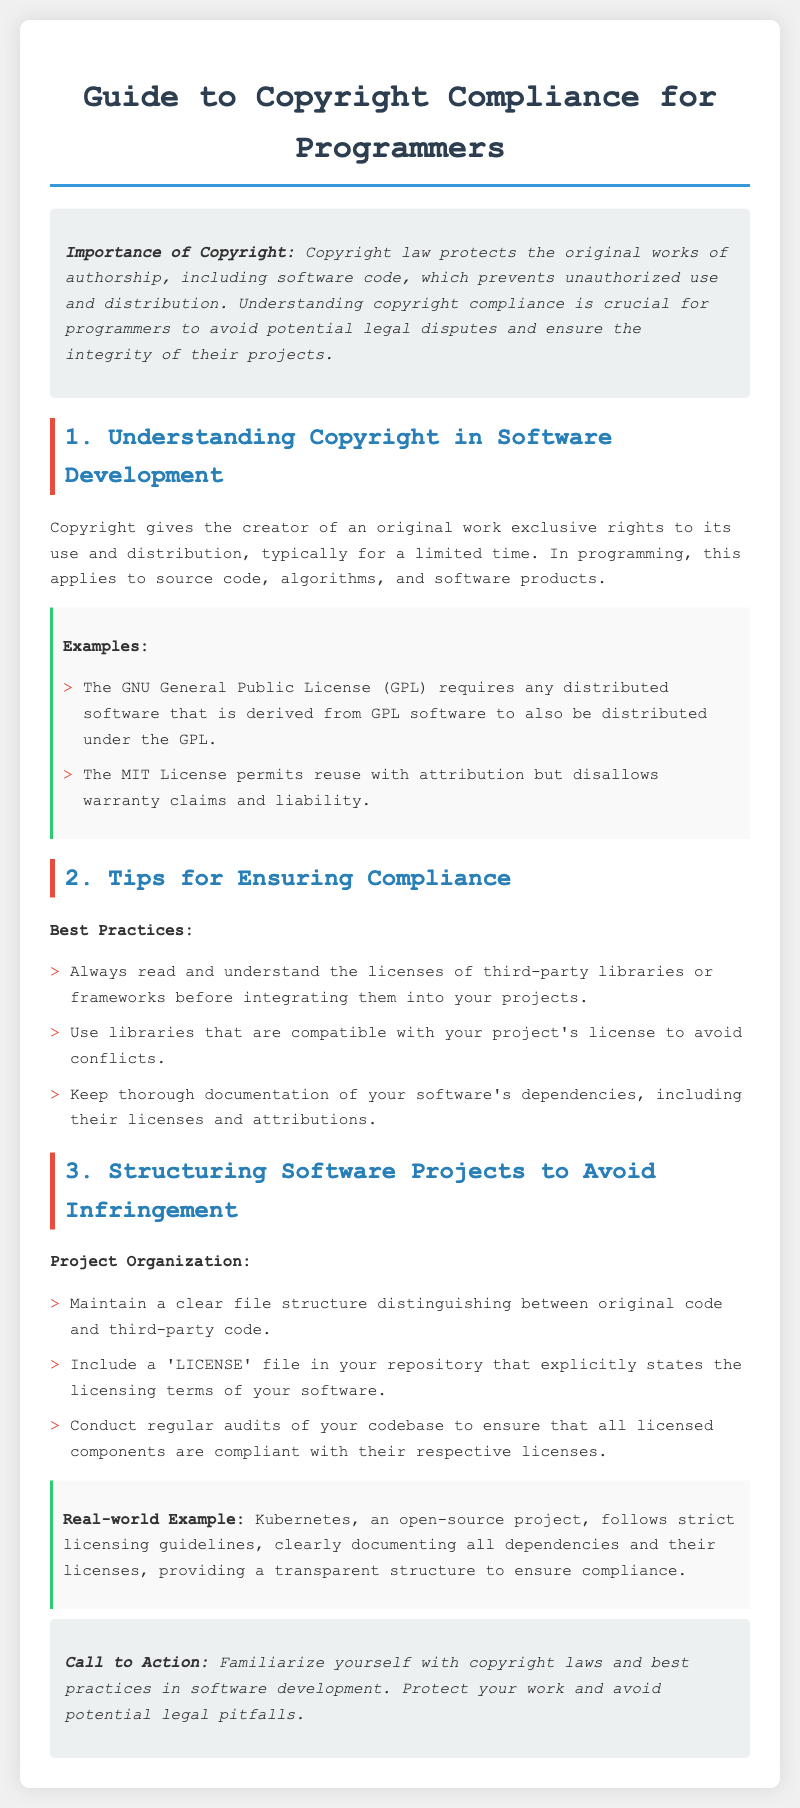What is the title of the document? The title of the document is specified in the `<title>` tag.
Answer: Guide to Copyright Compliance for Programmers What does copyright protect? The introduction discusses what copyright law covers in relation to software.
Answer: Original works of authorship What are the licenses mentioned in the examples? The examples section lists specific licenses relevant to programming.
Answer: GNU General Public License and MIT License What is a best practice for compliance? The section on tips provides specific practices for programmers.
Answer: Read and understand licenses What should be included in the repository? The project organization section suggests a necessary file for clarity.
Answer: A 'LICENSE' file What is a real-world example given in the document? The document includes an example of an open-source project to demonstrate compliance practices.
Answer: Kubernetes What should programmers maintain to avoid infringement? The project organization section advises on file management.
Answer: A clear file structure How often should software codebases be audited? The document implies the frequency of audits through its recommendations.
Answer: Regularly 